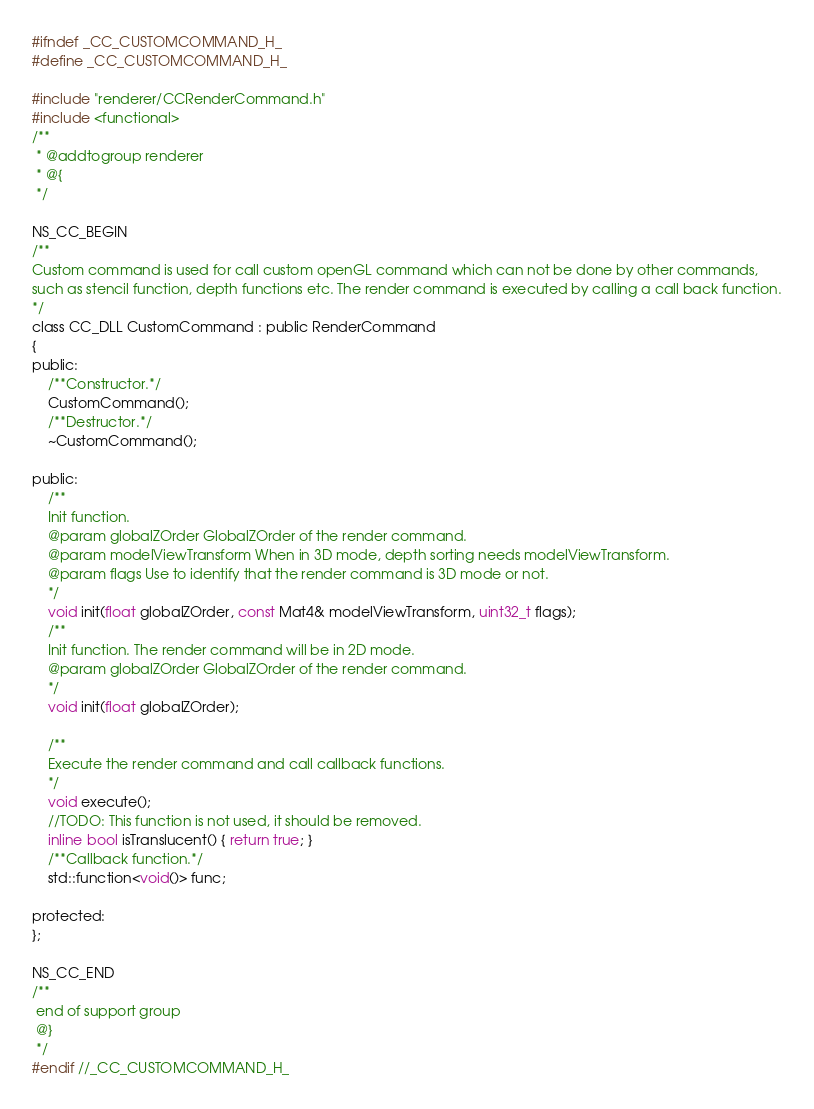<code> <loc_0><loc_0><loc_500><loc_500><_C_>
#ifndef _CC_CUSTOMCOMMAND_H_
#define _CC_CUSTOMCOMMAND_H_

#include "renderer/CCRenderCommand.h"
#include <functional>
/**
 * @addtogroup renderer
 * @{
 */

NS_CC_BEGIN
/**
Custom command is used for call custom openGL command which can not be done by other commands,
such as stencil function, depth functions etc. The render command is executed by calling a call back function.
*/
class CC_DLL CustomCommand : public RenderCommand
{
public:
	/**Constructor.*/
    CustomCommand();
    /**Destructor.*/
    ~CustomCommand();
    
public:
	/**
	Init function.
	@param globalZOrder GlobalZOrder of the render command.
	@param modelViewTransform When in 3D mode, depth sorting needs modelViewTransform.
	@param flags Use to identify that the render command is 3D mode or not.
	*/
    void init(float globalZOrder, const Mat4& modelViewTransform, uint32_t flags);
    /**
    Init function. The render command will be in 2D mode.
    @param globalZOrder GlobalZOrder of the render command.
    */
    void init(float globalZOrder);

    /**
    Execute the render command and call callback functions.
    */
    void execute();
    //TODO: This function is not used, it should be removed.
    inline bool isTranslucent() { return true; }
    /**Callback function.*/
    std::function<void()> func;

protected:
};

NS_CC_END
/**
 end of support group
 @}
 */
#endif //_CC_CUSTOMCOMMAND_H_
</code> 